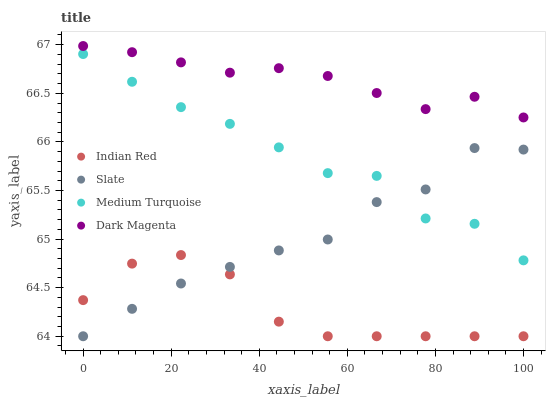Does Indian Red have the minimum area under the curve?
Answer yes or no. Yes. Does Dark Magenta have the maximum area under the curve?
Answer yes or no. Yes. Does Medium Turquoise have the minimum area under the curve?
Answer yes or no. No. Does Medium Turquoise have the maximum area under the curve?
Answer yes or no. No. Is Dark Magenta the smoothest?
Answer yes or no. Yes. Is Medium Turquoise the roughest?
Answer yes or no. Yes. Is Indian Red the smoothest?
Answer yes or no. No. Is Indian Red the roughest?
Answer yes or no. No. Does Slate have the lowest value?
Answer yes or no. Yes. Does Medium Turquoise have the lowest value?
Answer yes or no. No. Does Dark Magenta have the highest value?
Answer yes or no. Yes. Does Medium Turquoise have the highest value?
Answer yes or no. No. Is Medium Turquoise less than Dark Magenta?
Answer yes or no. Yes. Is Dark Magenta greater than Medium Turquoise?
Answer yes or no. Yes. Does Indian Red intersect Slate?
Answer yes or no. Yes. Is Indian Red less than Slate?
Answer yes or no. No. Is Indian Red greater than Slate?
Answer yes or no. No. Does Medium Turquoise intersect Dark Magenta?
Answer yes or no. No. 